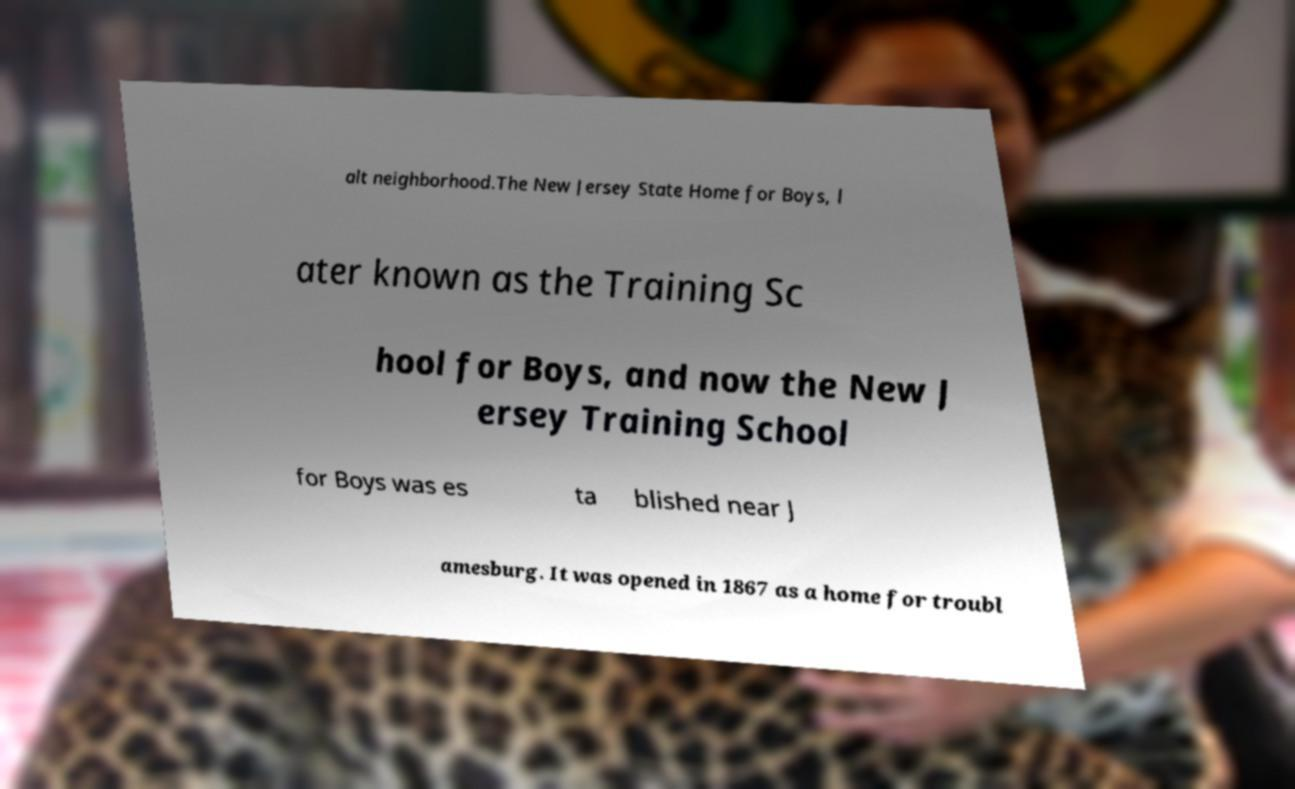For documentation purposes, I need the text within this image transcribed. Could you provide that? alt neighborhood.The New Jersey State Home for Boys, l ater known as the Training Sc hool for Boys, and now the New J ersey Training School for Boys was es ta blished near J amesburg. It was opened in 1867 as a home for troubl 